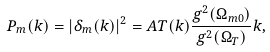Convert formula to latex. <formula><loc_0><loc_0><loc_500><loc_500>P _ { m } ( k ) = | \delta _ { m } ( k ) | ^ { 2 } = A T ( k ) \frac { g ^ { 2 } ( \Omega _ { m 0 } ) } { g ^ { 2 } ( \Omega _ { T } ) } k ,</formula> 